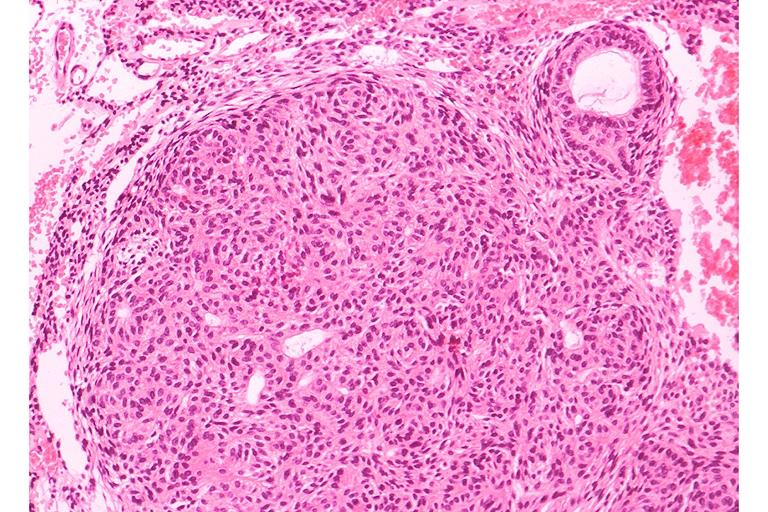does this image show adenomatoid odontogenic tumor?
Answer the question using a single word or phrase. Yes 